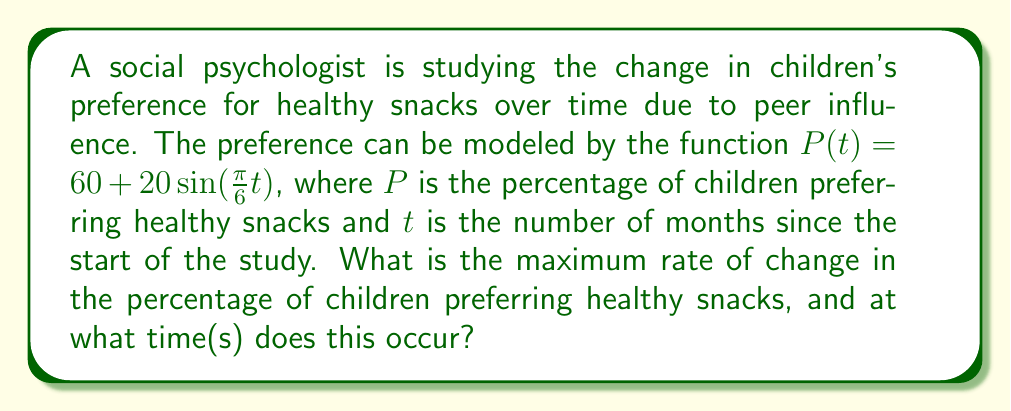Solve this math problem. To solve this problem, we need to follow these steps:

1) The rate of change is given by the derivative of the function. Let's find $P'(t)$:

   $P'(t) = 20 \cdot \frac{\pi}{6} \cos(\frac{\pi}{6}t)$
   
   $P'(t) = \frac{10\pi}{3} \cos(\frac{\pi}{6}t)$

2) The maximum rate of change will occur when $\cos(\frac{\pi}{6}t)$ is at its maximum, which is 1 or -1.

3) The absolute value of $P'(t)$ will be maximum when $\cos(\frac{\pi}{6}t) = \pm 1$:

   $|P'(t)|_{max} = |\frac{10\pi}{3}| \approx 10.47$

4) To find when this occurs, we need to solve:

   $\cos(\frac{\pi}{6}t) = \pm 1$

5) This occurs when $\frac{\pi}{6}t = 0, \pi, 2\pi, ...$ for positive maximum, and when $\frac{\pi}{6}t = \frac{\pi}{2}, \frac{3\pi}{2}, ...$ for negative maximum.

6) Solving for t:
   
   For positive maximum: $t = 0, 12, 24, ...$ months
   For negative maximum: $t = 3, 15, 27, ...$ months

Therefore, the maximum rate of change is approximately 10.47% per month, occurring every 3 months, alternating between positive and negative.
Answer: The maximum rate of change is $\frac{10\pi}{3} \approx 10.47\%$ per month, occurring at $t = 0, 3, 12, 15, 24, 27, ...$ months, alternating between positive and negative. 